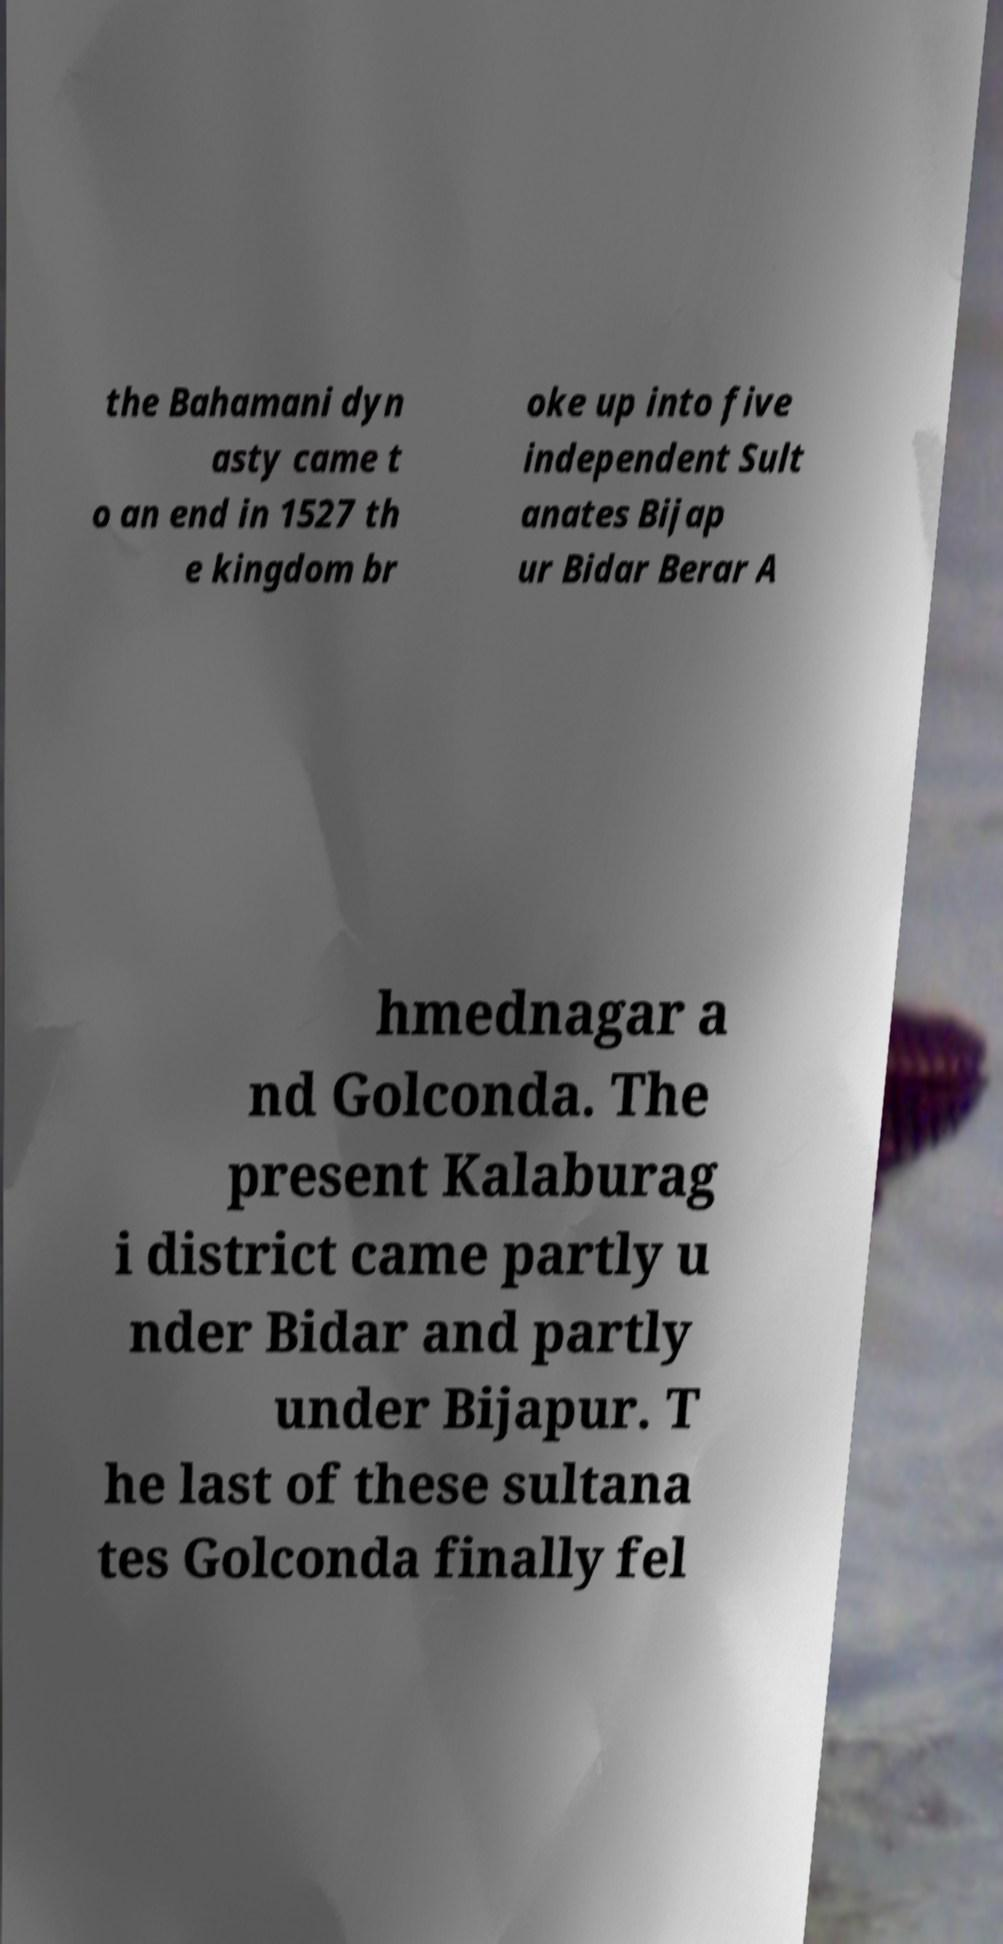Can you accurately transcribe the text from the provided image for me? the Bahamani dyn asty came t o an end in 1527 th e kingdom br oke up into five independent Sult anates Bijap ur Bidar Berar A hmednagar a nd Golconda. The present Kalaburag i district came partly u nder Bidar and partly under Bijapur. T he last of these sultana tes Golconda finally fel 